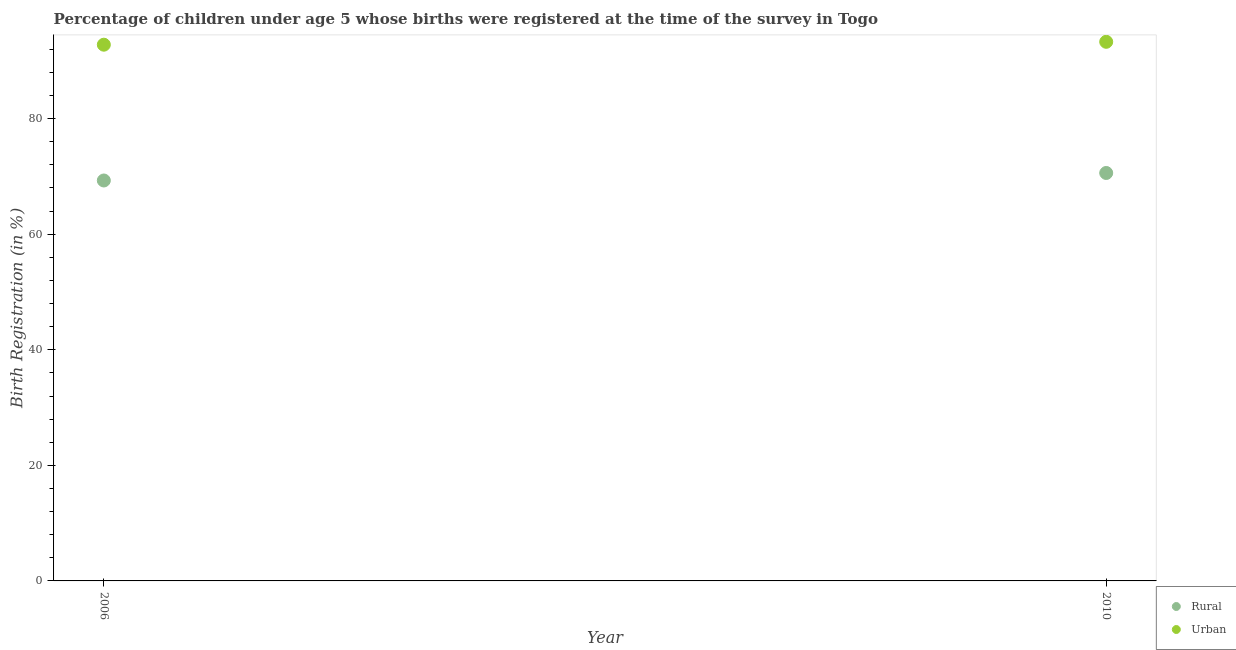How many different coloured dotlines are there?
Give a very brief answer. 2. Is the number of dotlines equal to the number of legend labels?
Your response must be concise. Yes. What is the urban birth registration in 2006?
Provide a succinct answer. 92.8. Across all years, what is the maximum urban birth registration?
Offer a terse response. 93.3. Across all years, what is the minimum rural birth registration?
Provide a short and direct response. 69.3. What is the total rural birth registration in the graph?
Give a very brief answer. 139.9. What is the average urban birth registration per year?
Provide a succinct answer. 93.05. In the year 2010, what is the difference between the urban birth registration and rural birth registration?
Ensure brevity in your answer.  22.7. In how many years, is the urban birth registration greater than 24 %?
Provide a short and direct response. 2. What is the ratio of the urban birth registration in 2006 to that in 2010?
Your answer should be compact. 0.99. Is the rural birth registration in 2006 less than that in 2010?
Keep it short and to the point. Yes. Is the rural birth registration strictly greater than the urban birth registration over the years?
Your answer should be compact. No. Is the rural birth registration strictly less than the urban birth registration over the years?
Your answer should be compact. Yes. How many years are there in the graph?
Keep it short and to the point. 2. Are the values on the major ticks of Y-axis written in scientific E-notation?
Keep it short and to the point. No. Does the graph contain grids?
Offer a terse response. No. Where does the legend appear in the graph?
Offer a terse response. Bottom right. How many legend labels are there?
Ensure brevity in your answer.  2. What is the title of the graph?
Your response must be concise. Percentage of children under age 5 whose births were registered at the time of the survey in Togo. What is the label or title of the Y-axis?
Offer a terse response. Birth Registration (in %). What is the Birth Registration (in %) in Rural in 2006?
Your response must be concise. 69.3. What is the Birth Registration (in %) of Urban in 2006?
Your response must be concise. 92.8. What is the Birth Registration (in %) of Rural in 2010?
Offer a very short reply. 70.6. What is the Birth Registration (in %) in Urban in 2010?
Make the answer very short. 93.3. Across all years, what is the maximum Birth Registration (in %) of Rural?
Ensure brevity in your answer.  70.6. Across all years, what is the maximum Birth Registration (in %) in Urban?
Provide a succinct answer. 93.3. Across all years, what is the minimum Birth Registration (in %) in Rural?
Your response must be concise. 69.3. Across all years, what is the minimum Birth Registration (in %) of Urban?
Provide a short and direct response. 92.8. What is the total Birth Registration (in %) in Rural in the graph?
Keep it short and to the point. 139.9. What is the total Birth Registration (in %) of Urban in the graph?
Your response must be concise. 186.1. What is the difference between the Birth Registration (in %) of Rural in 2006 and that in 2010?
Give a very brief answer. -1.3. What is the difference between the Birth Registration (in %) in Rural in 2006 and the Birth Registration (in %) in Urban in 2010?
Make the answer very short. -24. What is the average Birth Registration (in %) of Rural per year?
Keep it short and to the point. 69.95. What is the average Birth Registration (in %) of Urban per year?
Offer a terse response. 93.05. In the year 2006, what is the difference between the Birth Registration (in %) of Rural and Birth Registration (in %) of Urban?
Offer a very short reply. -23.5. In the year 2010, what is the difference between the Birth Registration (in %) of Rural and Birth Registration (in %) of Urban?
Ensure brevity in your answer.  -22.7. What is the ratio of the Birth Registration (in %) in Rural in 2006 to that in 2010?
Make the answer very short. 0.98. What is the difference between the highest and the second highest Birth Registration (in %) of Rural?
Offer a very short reply. 1.3. What is the difference between the highest and the lowest Birth Registration (in %) in Urban?
Offer a terse response. 0.5. 